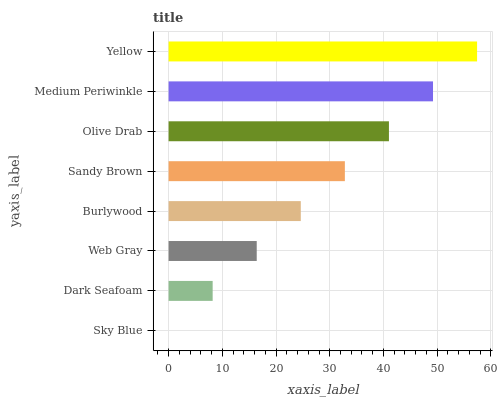Is Sky Blue the minimum?
Answer yes or no. Yes. Is Yellow the maximum?
Answer yes or no. Yes. Is Dark Seafoam the minimum?
Answer yes or no. No. Is Dark Seafoam the maximum?
Answer yes or no. No. Is Dark Seafoam greater than Sky Blue?
Answer yes or no. Yes. Is Sky Blue less than Dark Seafoam?
Answer yes or no. Yes. Is Sky Blue greater than Dark Seafoam?
Answer yes or no. No. Is Dark Seafoam less than Sky Blue?
Answer yes or no. No. Is Sandy Brown the high median?
Answer yes or no. Yes. Is Burlywood the low median?
Answer yes or no. Yes. Is Sky Blue the high median?
Answer yes or no. No. Is Sky Blue the low median?
Answer yes or no. No. 